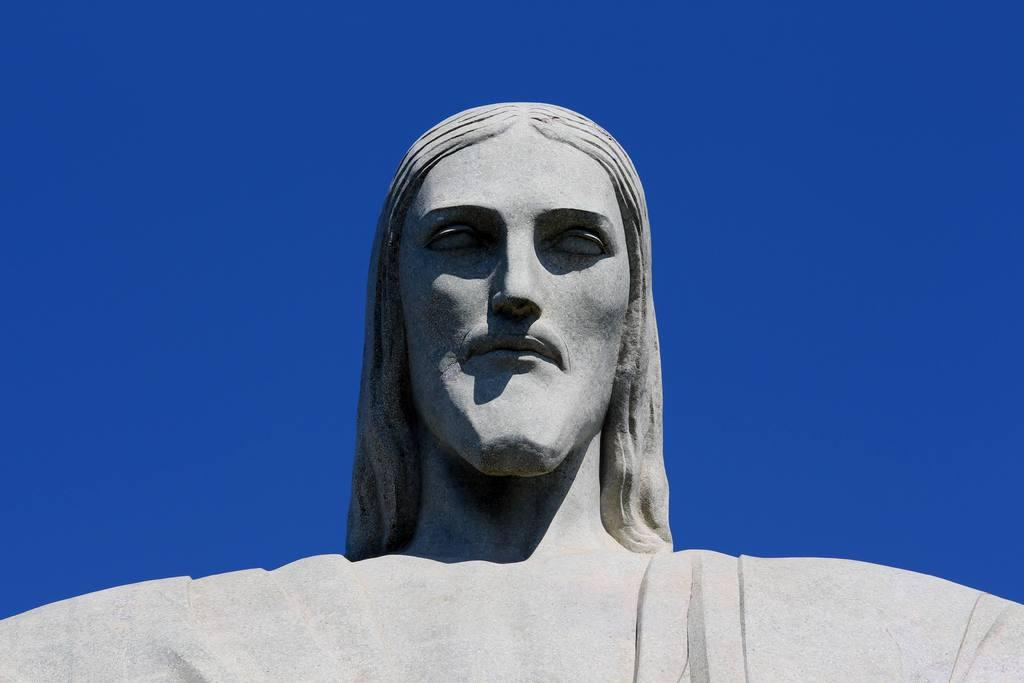What is the main subject of the image? There is a sculpture of a person in the image. What type of lumber is used to create the sculpture in the image? There is no information provided about the materials used to create the sculpture, so it cannot be determined from the image. 